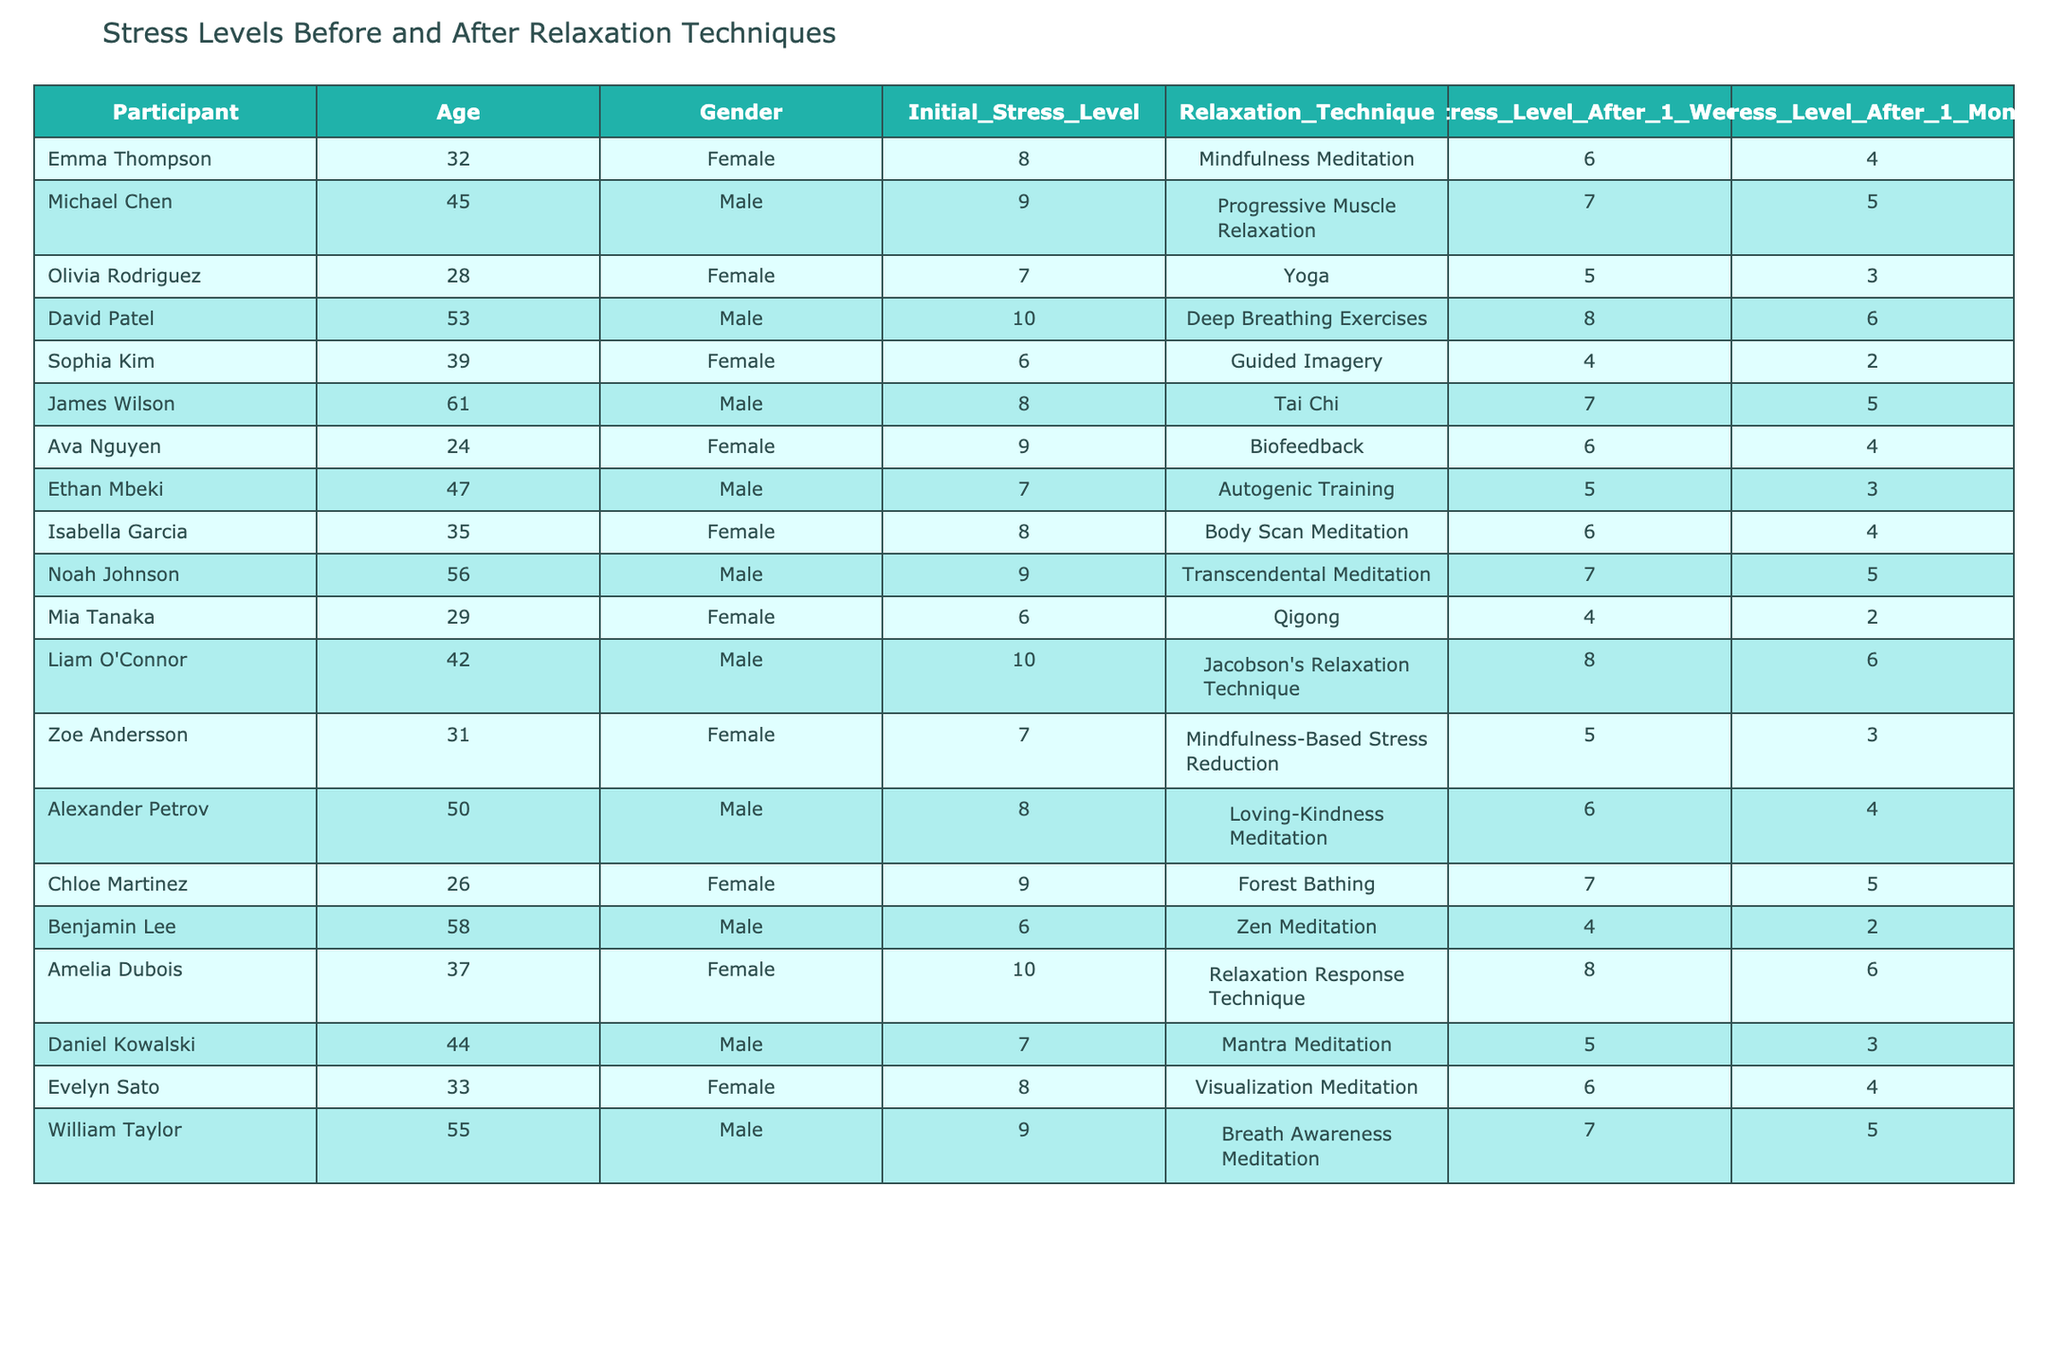What was Emma Thompson's initial stress level? By referring to the table, Emma Thompson's initial stress level is listed under the "Initial_Stress_Level" column, which is recorded as 8.
Answer: 8 Which relaxation technique did Olivia Rodriguez use? According to the table, Olivia Rodriguez utilized the "Yoga" relaxation technique, as indicated in the "Relaxation_Technique" column.
Answer: Yoga What is the difference in stress level for Michael Chen after one month compared to his initial stress level? Michael Chen's initial stress level is 9, and his stress level after one month is 5. The difference is calculated as 9 - 5 = 4.
Answer: 4 What is the gender of the participant with the highest initial stress level? According to the table, the participant with the highest initial stress level is David Patel, who is male.
Answer: Male Did any participants experience a stress level of 2 after one month? Yes, both Sophia Kim and Benjamin Lee experienced a stress level of 2 after one month, as indicated in the table.
Answer: Yes What was the average initial stress level of all participants? To find the average initial stress level, first, sum all initial stress levels: 8 + 9 + 7 + 10 + 6 + 8 + 9 + 7 + 8 + 9 + 6 + 10 + 7 + 8 + 6 + 10 + 7 + 9 = 139. Then divide by the number of participants (18): 139 / 18 ≈ 7.72.
Answer: Approximately 7.72 Which relaxation technique had the most participants achieving a stress level of 4 after one month? Looking at the table, we see that there are three participants—Sophia Kim, Isabella Garcia, and Alexander Petrov—who achieved a stress level of 4 after one month using different techniques.
Answer: Mindfulness Meditation, Body Scan Meditation, Loving-Kindness Meditation What is the trend of stress levels before and after implementing relaxation techniques for participants aged 30 or younger? The stress levels before implementing techniques are 7 (Olivia Rodriguez), 9 (Ava Nguyen), and 6 (Mia Tanaka). After one month, their stress levels dropped to 3, 4, and 2, respectively. This indicates a downward trend in stress levels for these participants.
Answer: Downward trend Is there a participant who reported no change in stress level after one month? Yes, Ava Nguyen reported a stress level of 6 before and after the relaxation technique, indicating no change in her stress level.
Answer: Yes How many of the participants used mindfulness-based techniques, and what was the average stress level after one month for these individuals? There are four participants using mindfulness techniques: Mindfulness Meditation (Emma), Mindfulness-Based Stress Reduction (Zoe), Loving-Kindness Meditation (Alexander), and Visualization Meditation (Evelyn). Their stress levels after one month are 4, 3, 4, and 4 respectively, giving an average of (4 + 3 + 4 + 4) / 4 = 3.75.
Answer: Average is 3.75 